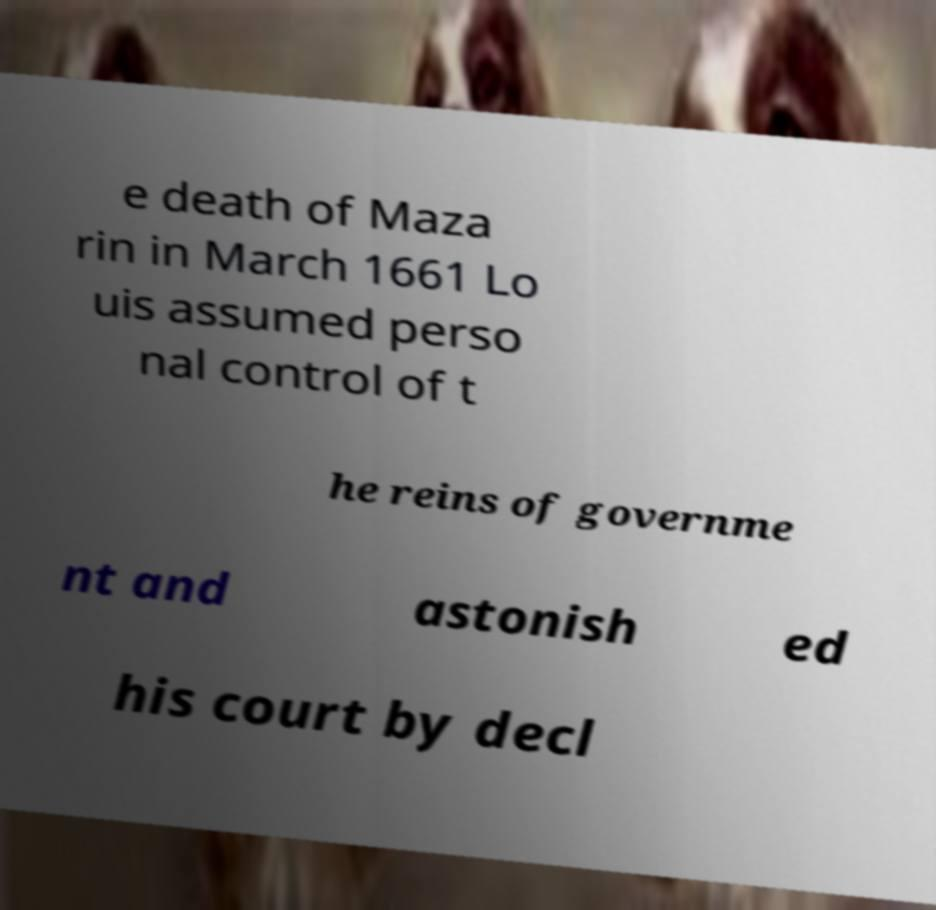There's text embedded in this image that I need extracted. Can you transcribe it verbatim? e death of Maza rin in March 1661 Lo uis assumed perso nal control of t he reins of governme nt and astonish ed his court by decl 